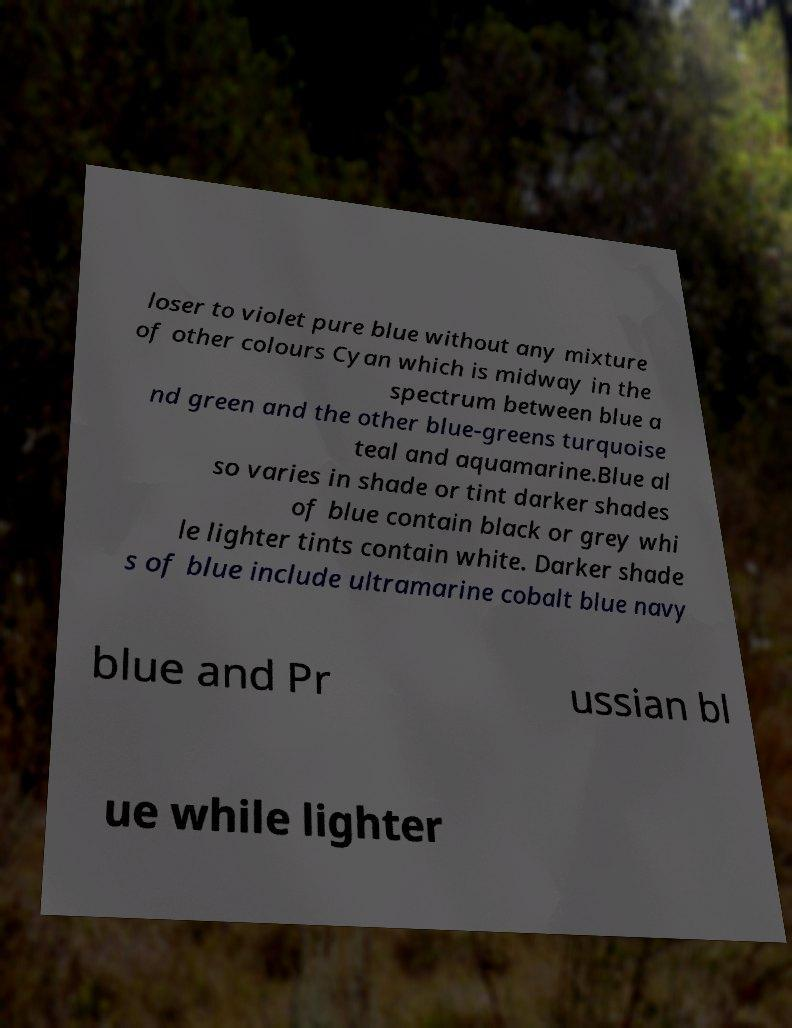For documentation purposes, I need the text within this image transcribed. Could you provide that? loser to violet pure blue without any mixture of other colours Cyan which is midway in the spectrum between blue a nd green and the other blue-greens turquoise teal and aquamarine.Blue al so varies in shade or tint darker shades of blue contain black or grey whi le lighter tints contain white. Darker shade s of blue include ultramarine cobalt blue navy blue and Pr ussian bl ue while lighter 